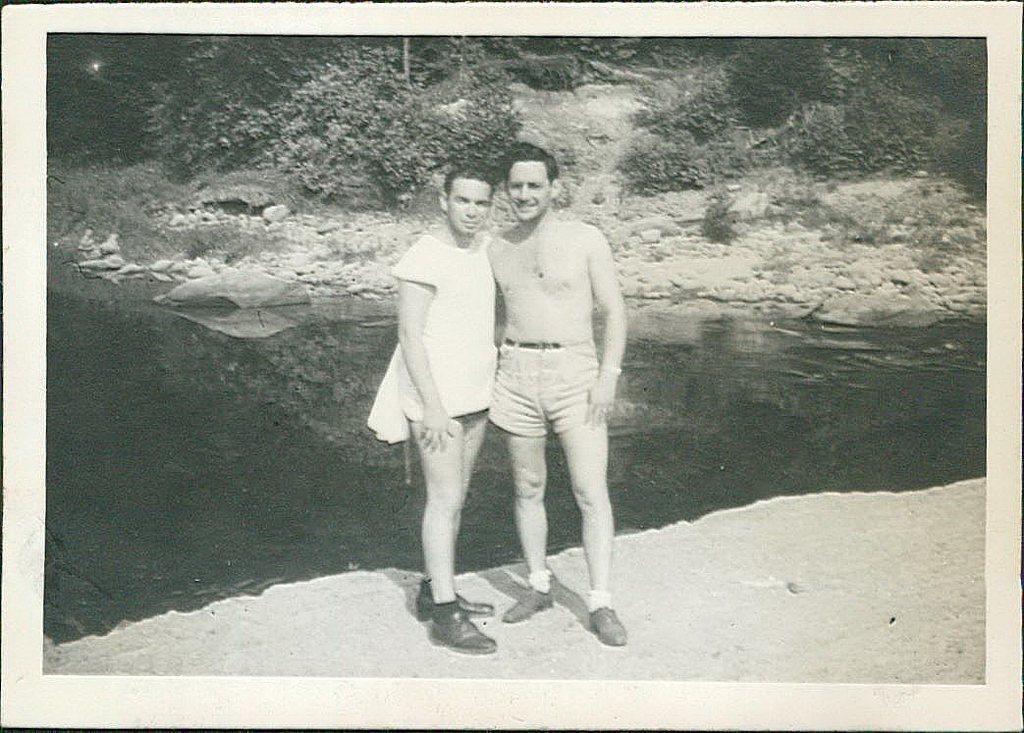What are the people in the image doing? The persons standing in the center of the image are smiling. Can you describe the environment in the image? There is water, stones, and trees visible in the background of the image. What might be the mood or atmosphere of the scene? The fact that the persons are smiling suggests a positive or happy mood. What type of dust can be seen floating in the air in the image? There is no dust visible in the image; it features persons standing in the center and a background with water, stones, and trees. 